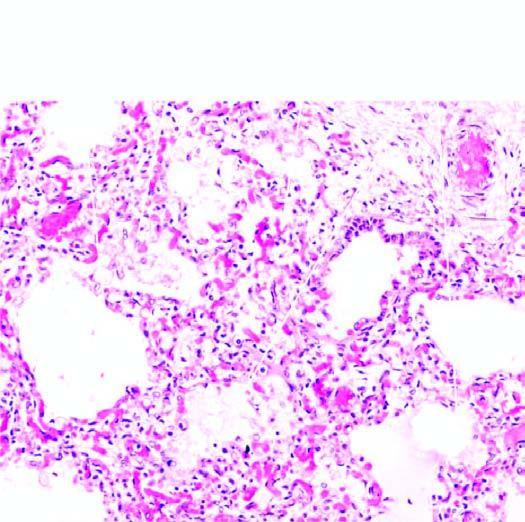what do the air spaces contain?
Answer the question using a single word or phrase. Pale oedema fluid and a few red cells 